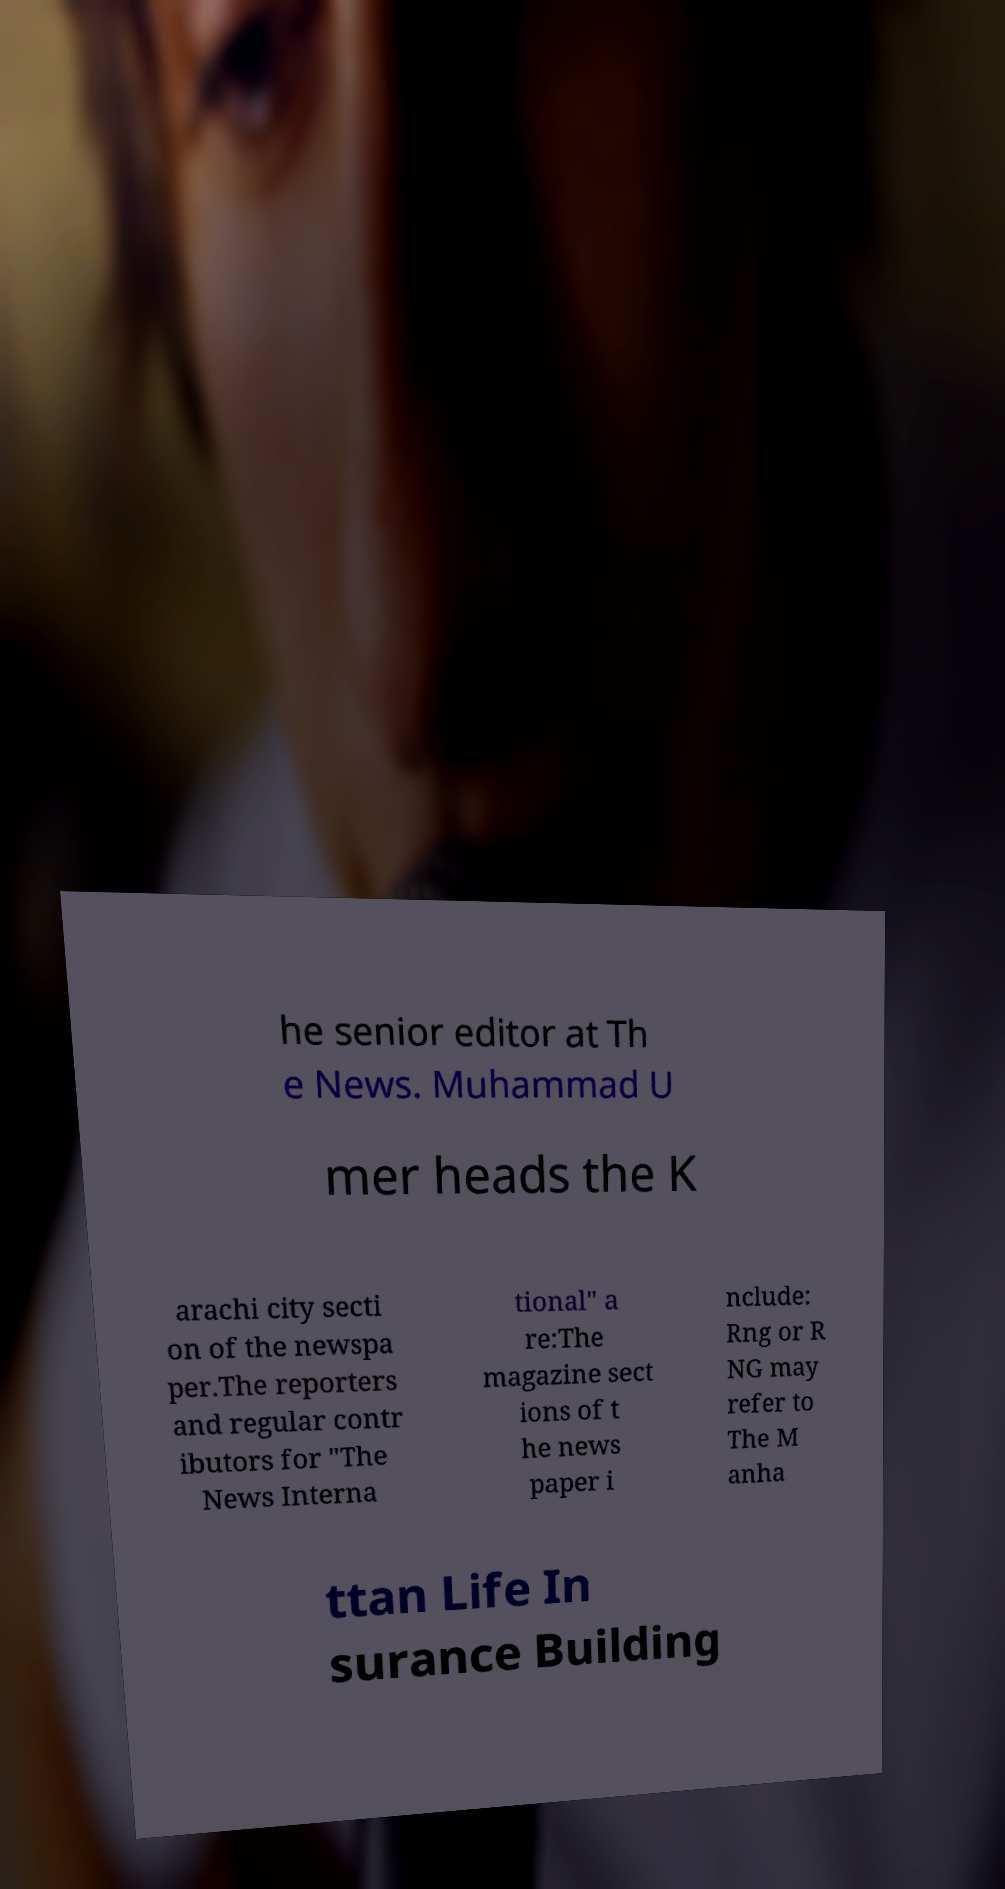Could you assist in decoding the text presented in this image and type it out clearly? he senior editor at Th e News. Muhammad U mer heads the K arachi city secti on of the newspa per.The reporters and regular contr ibutors for "The News Interna tional" a re:The magazine sect ions of t he news paper i nclude: Rng or R NG may refer to The M anha ttan Life In surance Building 